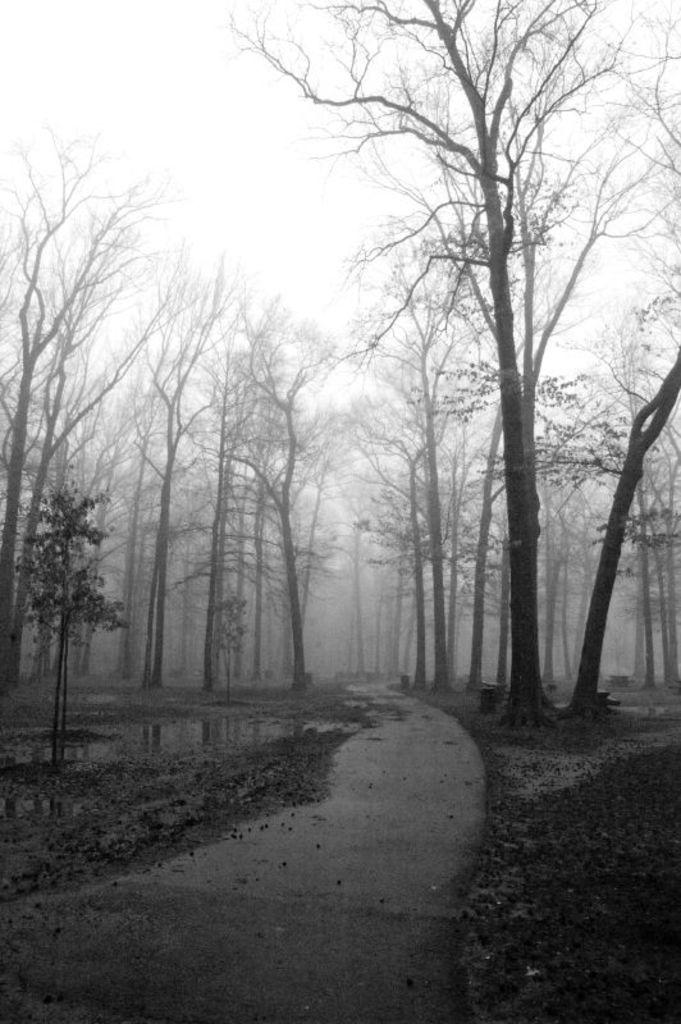What is the color scheme of the image? The image is black and white. Where was the image taken? The image was taken outside. What type of vegetation can be seen in the image? There are trees in the image. What is visible at the top of the image? The sky is visible at the top of the image. How many eggs are visible in the image? There are no eggs present in the image. What type of process is being carried out in the image? There is no process being carried out in the image; it is a static scene featuring trees and the sky. 